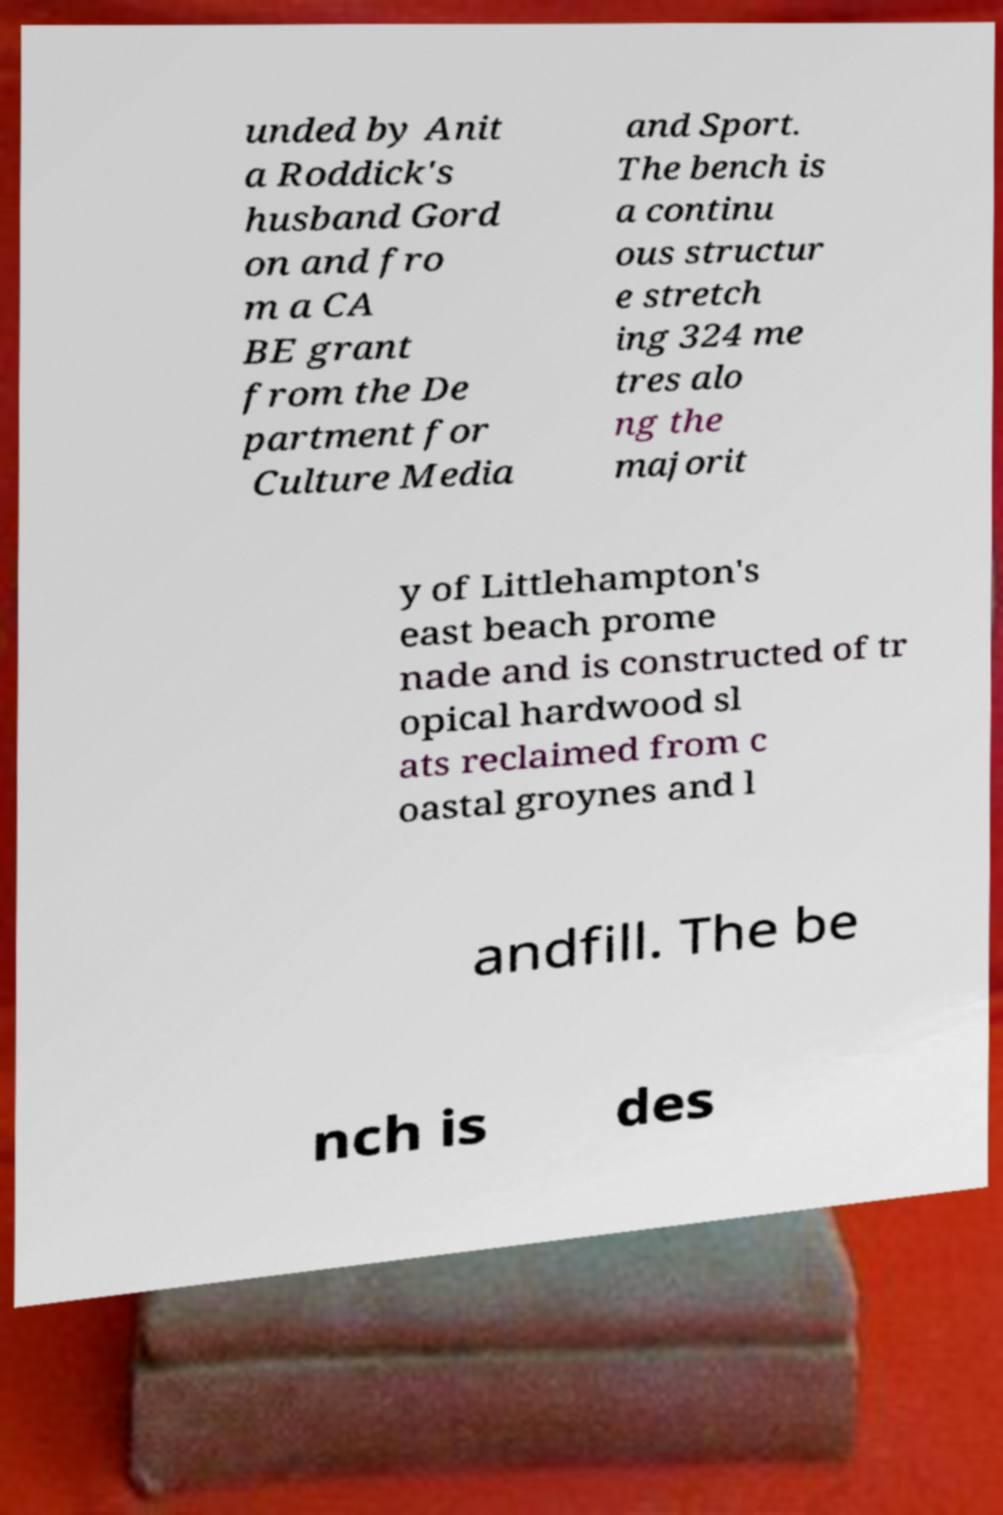Can you read and provide the text displayed in the image?This photo seems to have some interesting text. Can you extract and type it out for me? unded by Anit a Roddick's husband Gord on and fro m a CA BE grant from the De partment for Culture Media and Sport. The bench is a continu ous structur e stretch ing 324 me tres alo ng the majorit y of Littlehampton's east beach prome nade and is constructed of tr opical hardwood sl ats reclaimed from c oastal groynes and l andfill. The be nch is des 